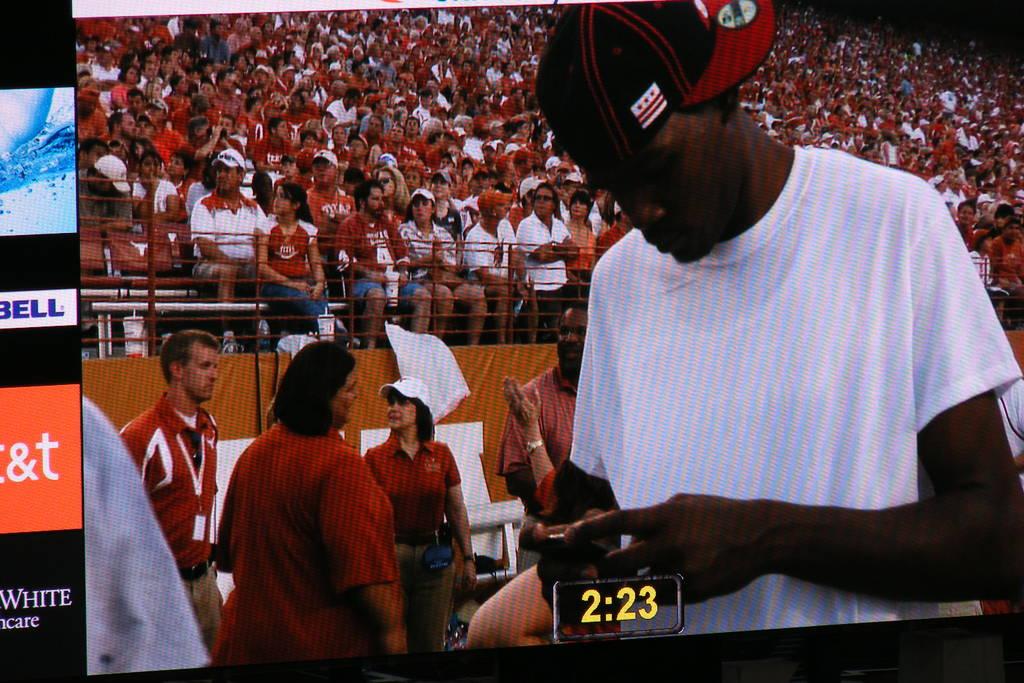What is the time at the bottom?
Provide a short and direct response. 2:23. 